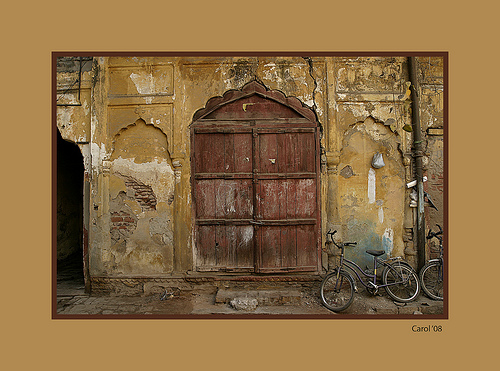Please provide a short description for this region: [0.64, 0.58, 0.84, 0.75]. A fully operational bicycle is leaning against the wall in this region, suggesting a brief pause in a bustling environment. 